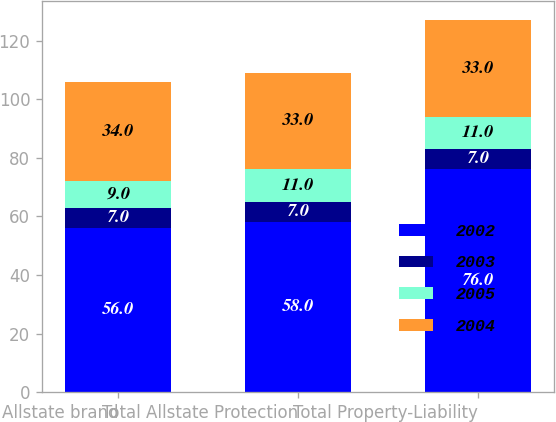<chart> <loc_0><loc_0><loc_500><loc_500><stacked_bar_chart><ecel><fcel>Allstate brand<fcel>Total Allstate Protection<fcel>Total Property-Liability<nl><fcel>2002<fcel>56<fcel>58<fcel>76<nl><fcel>2003<fcel>7<fcel>7<fcel>7<nl><fcel>2005<fcel>9<fcel>11<fcel>11<nl><fcel>2004<fcel>34<fcel>33<fcel>33<nl></chart> 